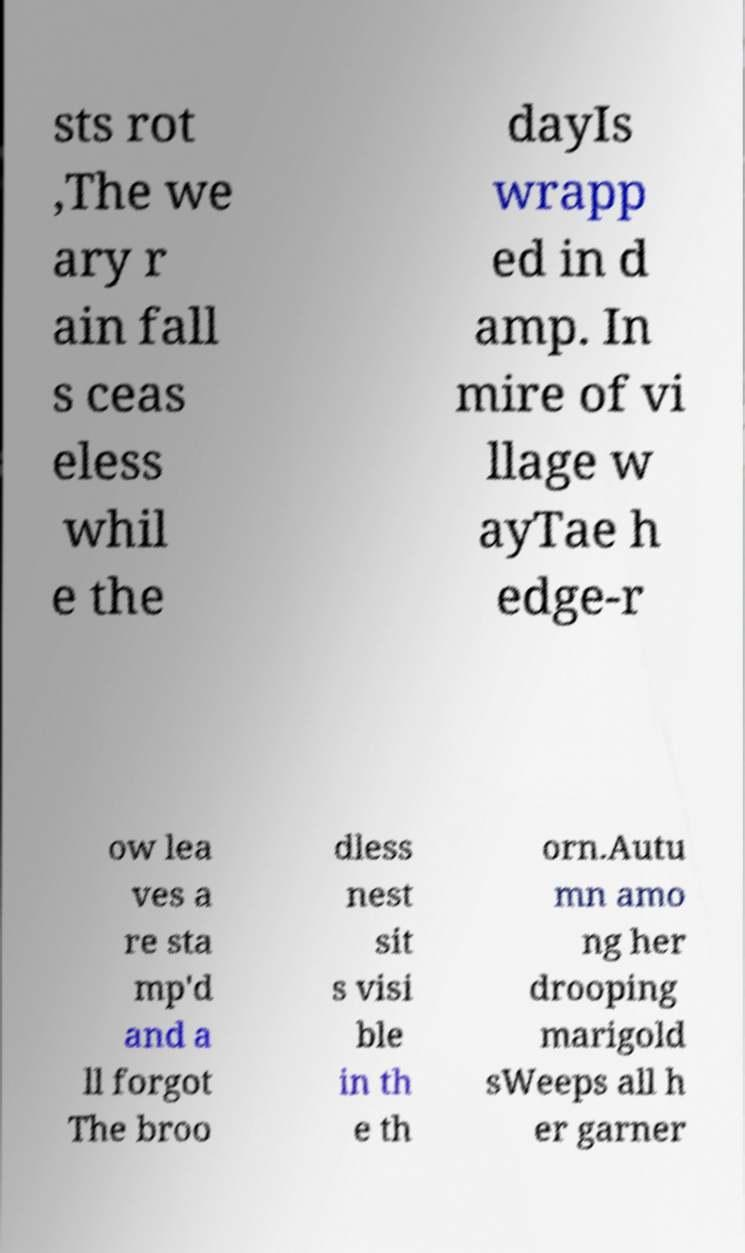There's text embedded in this image that I need extracted. Can you transcribe it verbatim? sts rot ,The we ary r ain fall s ceas eless whil e the dayIs wrapp ed in d amp. In mire of vi llage w ayTae h edge-r ow lea ves a re sta mp'd and a ll forgot The broo dless nest sit s visi ble in th e th orn.Autu mn amo ng her drooping marigold sWeeps all h er garner 